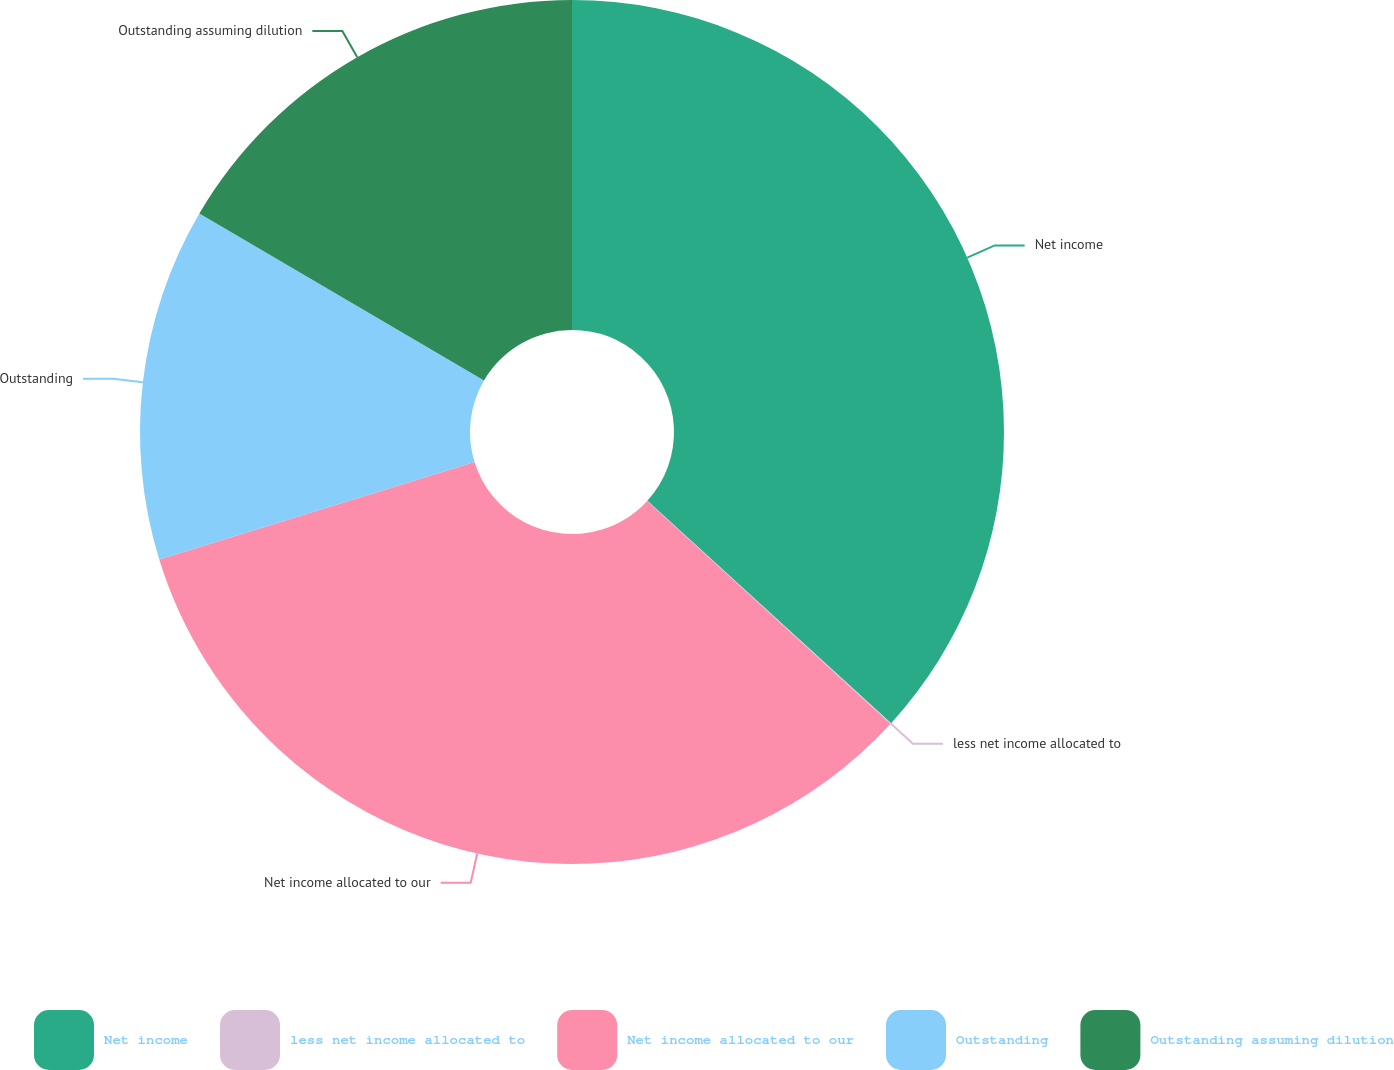Convert chart to OTSL. <chart><loc_0><loc_0><loc_500><loc_500><pie_chart><fcel>Net income<fcel>less net income allocated to<fcel>Net income allocated to our<fcel>Outstanding<fcel>Outstanding assuming dilution<nl><fcel>36.77%<fcel>0.04%<fcel>33.42%<fcel>13.21%<fcel>16.56%<nl></chart> 